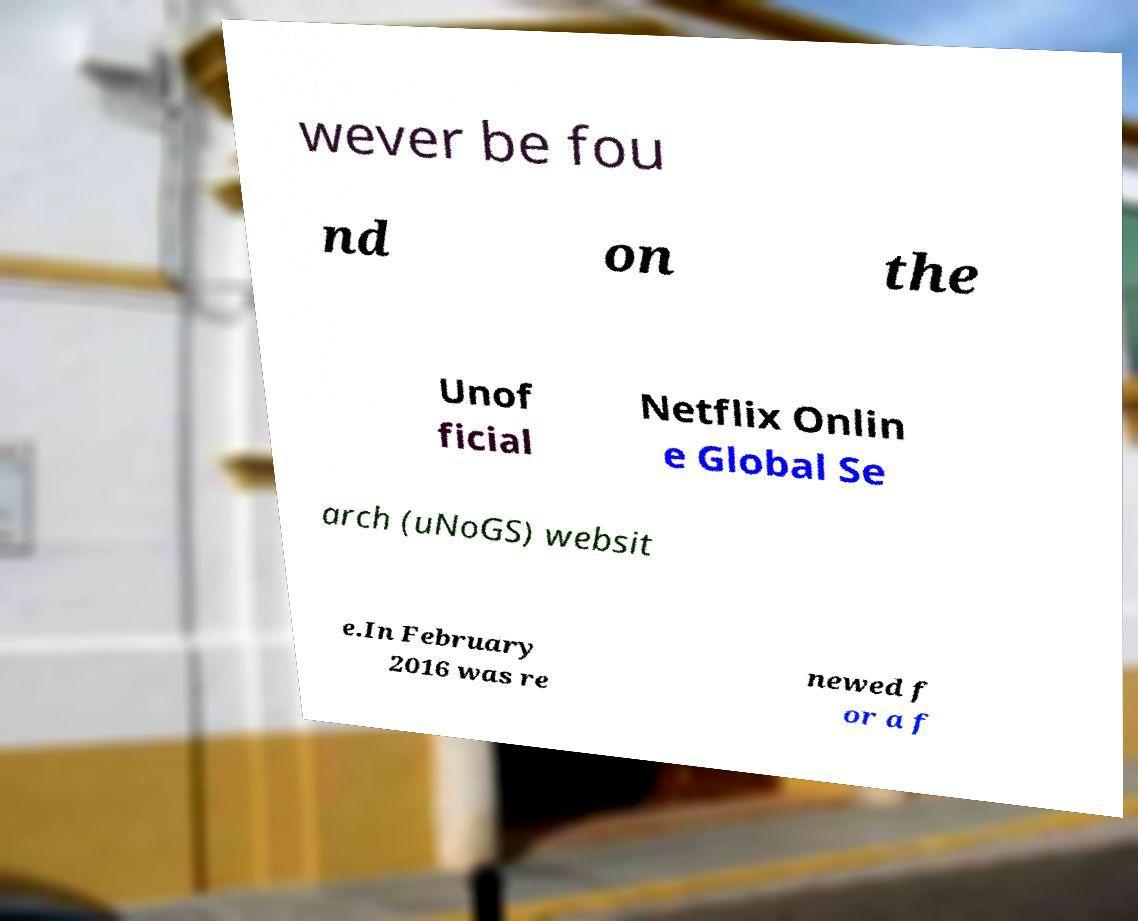Please identify and transcribe the text found in this image. wever be fou nd on the Unof ficial Netflix Onlin e Global Se arch (uNoGS) websit e.In February 2016 was re newed f or a f 